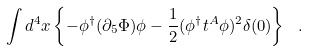Convert formula to latex. <formula><loc_0><loc_0><loc_500><loc_500>\int d ^ { 4 } x \left \{ - \phi ^ { \dagger } ( \partial _ { 5 } \Phi ) \phi - \frac { 1 } { 2 } ( \phi ^ { \dagger } t ^ { A } \phi ) ^ { 2 } \delta ( 0 ) \right \} \ .</formula> 